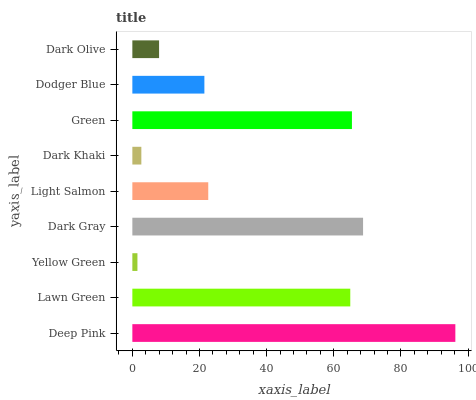Is Yellow Green the minimum?
Answer yes or no. Yes. Is Deep Pink the maximum?
Answer yes or no. Yes. Is Lawn Green the minimum?
Answer yes or no. No. Is Lawn Green the maximum?
Answer yes or no. No. Is Deep Pink greater than Lawn Green?
Answer yes or no. Yes. Is Lawn Green less than Deep Pink?
Answer yes or no. Yes. Is Lawn Green greater than Deep Pink?
Answer yes or no. No. Is Deep Pink less than Lawn Green?
Answer yes or no. No. Is Light Salmon the high median?
Answer yes or no. Yes. Is Light Salmon the low median?
Answer yes or no. Yes. Is Lawn Green the high median?
Answer yes or no. No. Is Yellow Green the low median?
Answer yes or no. No. 